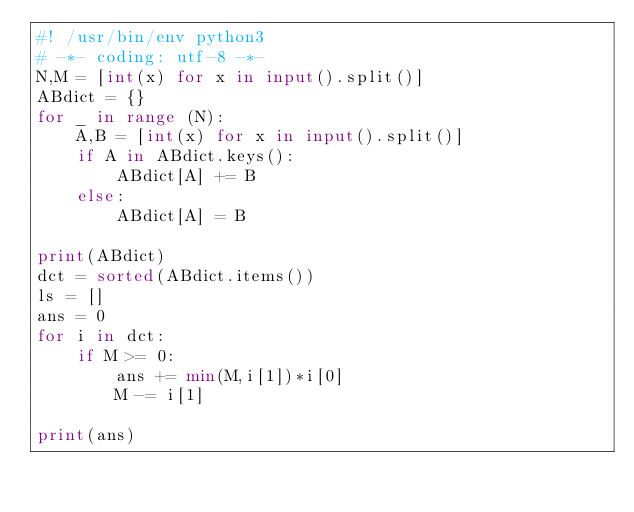<code> <loc_0><loc_0><loc_500><loc_500><_Python_>#! /usr/bin/env python3
# -*- coding: utf-8 -*-
N,M = [int(x) for x in input().split()]
ABdict = {}
for _ in range (N):
    A,B = [int(x) for x in input().split()]
    if A in ABdict.keys():
        ABdict[A] += B
    else:
        ABdict[A] = B

print(ABdict)
dct = sorted(ABdict.items())
ls = []
ans = 0
for i in dct:
    if M >= 0:
        ans += min(M,i[1])*i[0]    
        M -= i[1]  

print(ans)
</code> 